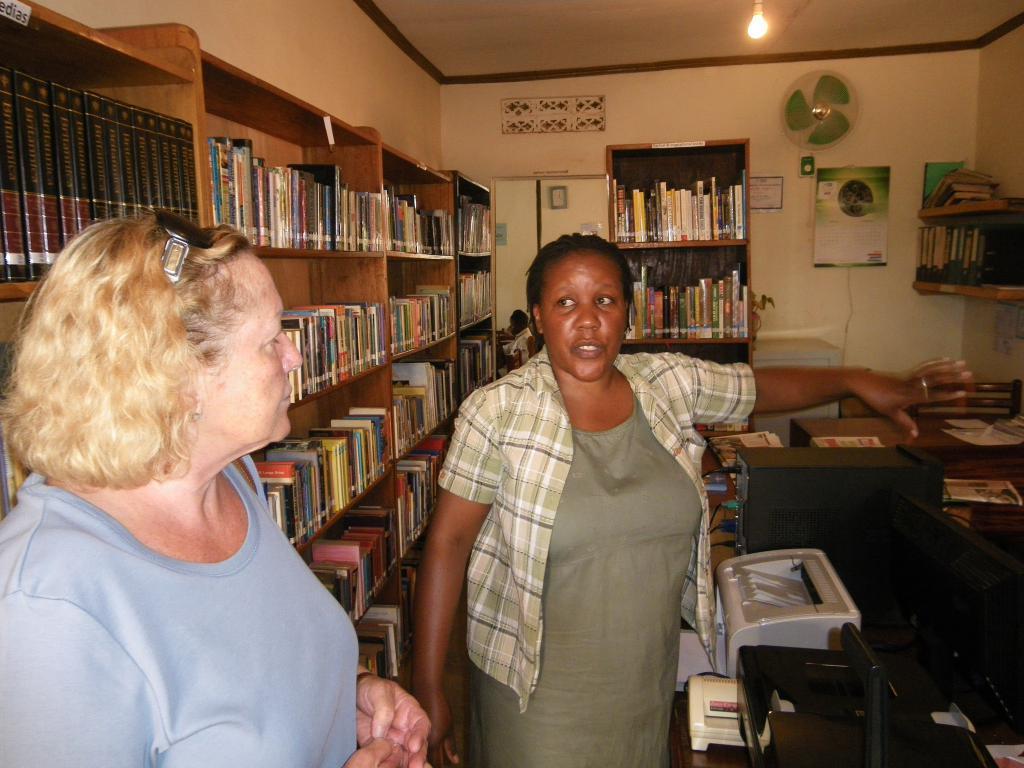In one or two sentences, can you explain what this image depicts? In this image there are two women standing and talking with each other. At the background there are shelves in which there are so many number of books. To the right side top corner there is a table fan and calendar to the wall. Beside the woman there is a printer and computer. At the top there is light. 